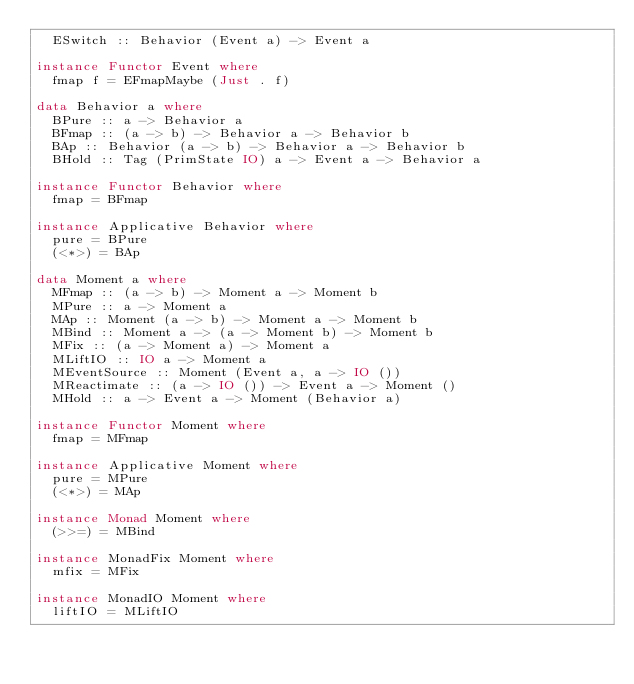<code> <loc_0><loc_0><loc_500><loc_500><_Haskell_>  ESwitch :: Behavior (Event a) -> Event a

instance Functor Event where
  fmap f = EFmapMaybe (Just . f)

data Behavior a where
  BPure :: a -> Behavior a
  BFmap :: (a -> b) -> Behavior a -> Behavior b
  BAp :: Behavior (a -> b) -> Behavior a -> Behavior b
  BHold :: Tag (PrimState IO) a -> Event a -> Behavior a

instance Functor Behavior where
  fmap = BFmap

instance Applicative Behavior where
  pure = BPure
  (<*>) = BAp

data Moment a where
  MFmap :: (a -> b) -> Moment a -> Moment b
  MPure :: a -> Moment a
  MAp :: Moment (a -> b) -> Moment a -> Moment b
  MBind :: Moment a -> (a -> Moment b) -> Moment b
  MFix :: (a -> Moment a) -> Moment a
  MLiftIO :: IO a -> Moment a
  MEventSource :: Moment (Event a, a -> IO ())
  MReactimate :: (a -> IO ()) -> Event a -> Moment ()
  MHold :: a -> Event a -> Moment (Behavior a)

instance Functor Moment where
  fmap = MFmap

instance Applicative Moment where
  pure = MPure
  (<*>) = MAp

instance Monad Moment where
  (>>=) = MBind

instance MonadFix Moment where
  mfix = MFix

instance MonadIO Moment where
  liftIO = MLiftIO
</code> 